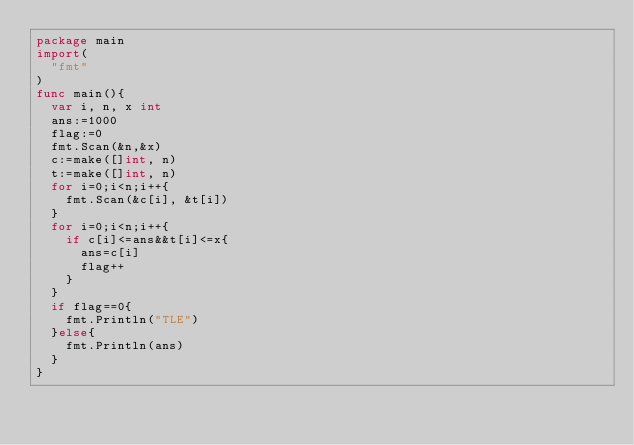Convert code to text. <code><loc_0><loc_0><loc_500><loc_500><_Go_>package main
import(
  "fmt"
)
func main(){
  var i, n, x int
  ans:=1000
  flag:=0
  fmt.Scan(&n,&x)
  c:=make([]int, n)
  t:=make([]int, n)
  for i=0;i<n;i++{
    fmt.Scan(&c[i], &t[i])
  }
  for i=0;i<n;i++{
    if c[i]<=ans&&t[i]<=x{
      ans=c[i]
      flag++
    }
  }
  if flag==0{
    fmt.Println("TLE")
  }else{
    fmt.Println(ans)
  }
}
</code> 